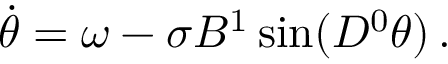Convert formula to latex. <formula><loc_0><loc_0><loc_500><loc_500>\begin{array} { r } { \ D o t { \theta } = \omega - \sigma B ^ { 1 } \sin ( D ^ { 0 } \theta ) \, . } \end{array}</formula> 